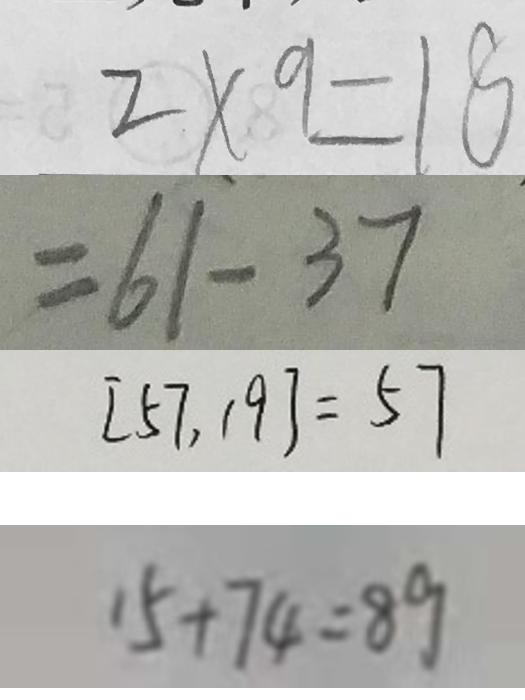<formula> <loc_0><loc_0><loc_500><loc_500>2 \times 9 = 1 8 
 = 6 1 - 3 7 
 [ 5 7 , 1 9 ] = 5 7 
 1 5 + 7 4 = 8 9</formula> 